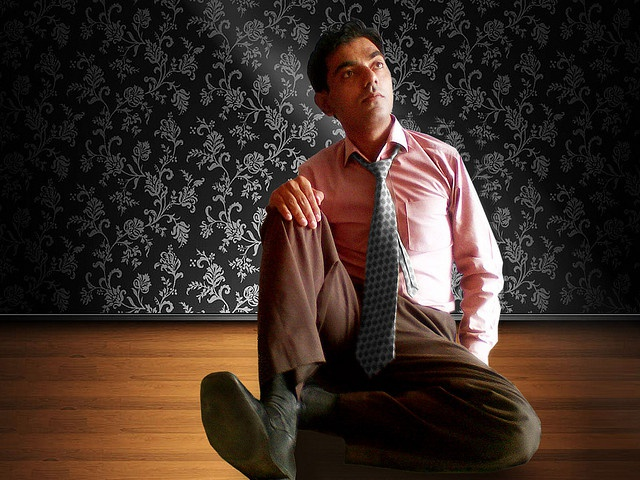Describe the objects in this image and their specific colors. I can see people in black, maroon, white, and brown tones and tie in black, gray, lightgray, and darkgray tones in this image. 